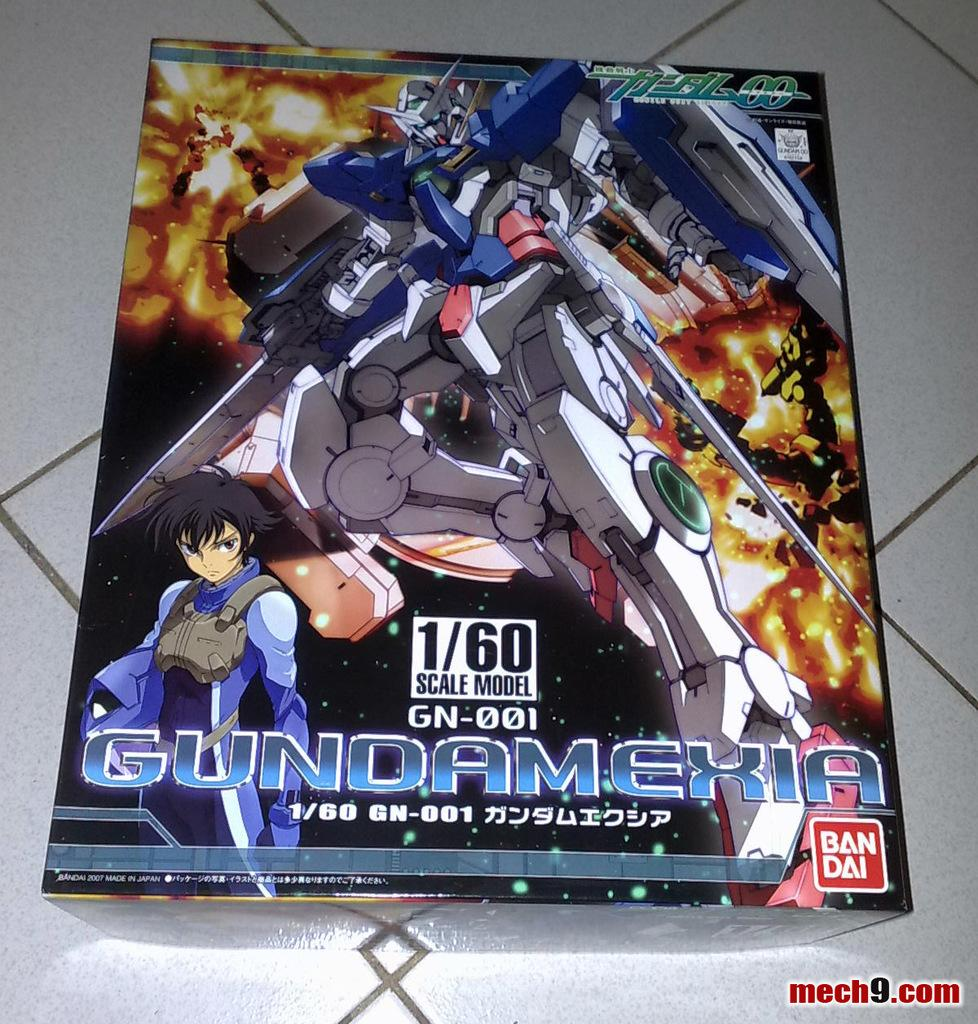<image>
Offer a succinct explanation of the picture presented. An image of a robot with Gubdamekia by Ban Dai with website mech9.com in the right corner. 